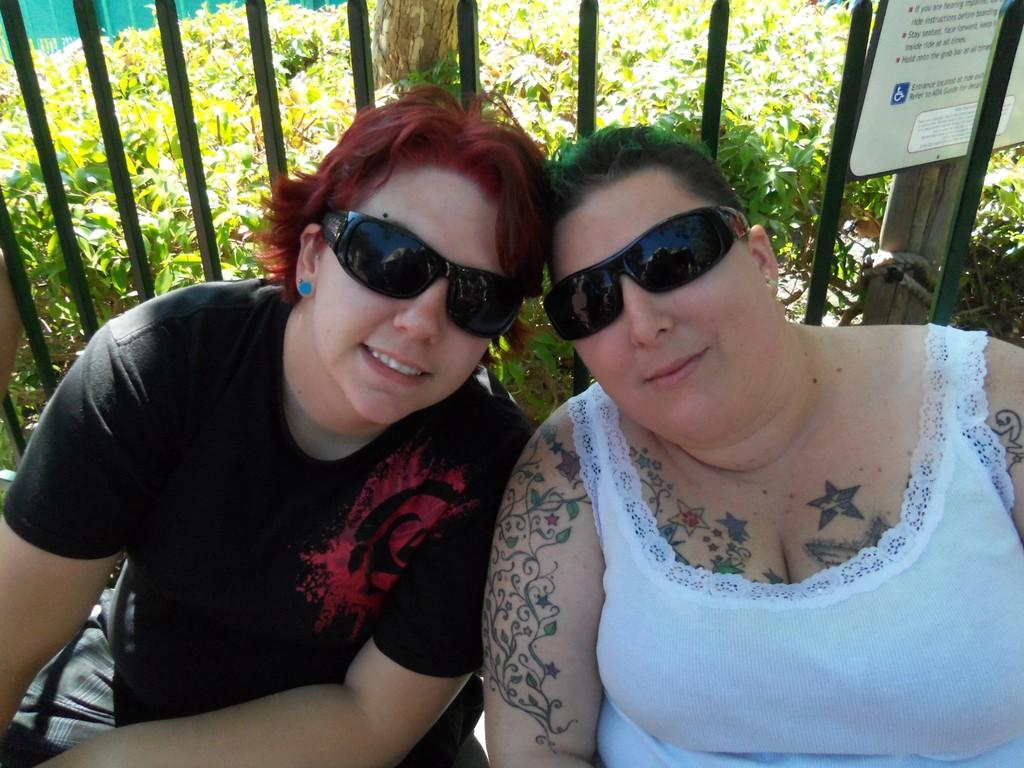How many women are present in the image? There are two women sitting in the image. What are the women wearing that is mentioned in the facts? The women are wearing glasses. What type of objects can be seen in the image that are made of metal? Metal poles are visible in the image. What is written or displayed on the board in the image? The facts do not specify what is written or displayed on the board, only that there is a board with text in the image. What type of pole is made of wood in the image? There is a wooden pole in the image. What type of vegetation is present in the image? Plants are present in the image. What type of barrier can be seen in the image? There is a fence in the image. How long does it take for the women to rest after their trail in the image? The facts do not mention any trail or resting activity, so it is not possible to determine how long it takes for the women to rest. 